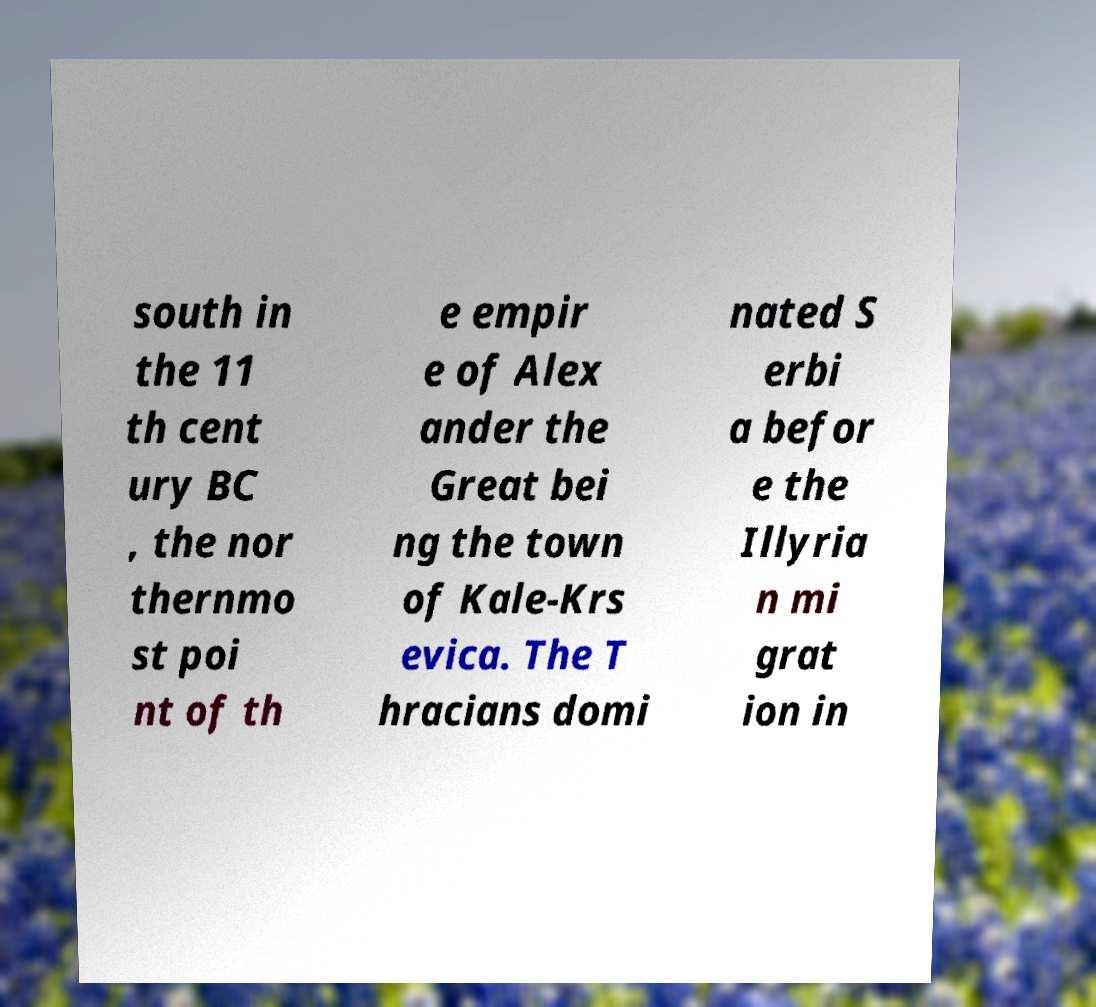Can you accurately transcribe the text from the provided image for me? south in the 11 th cent ury BC , the nor thernmo st poi nt of th e empir e of Alex ander the Great bei ng the town of Kale-Krs evica. The T hracians domi nated S erbi a befor e the Illyria n mi grat ion in 